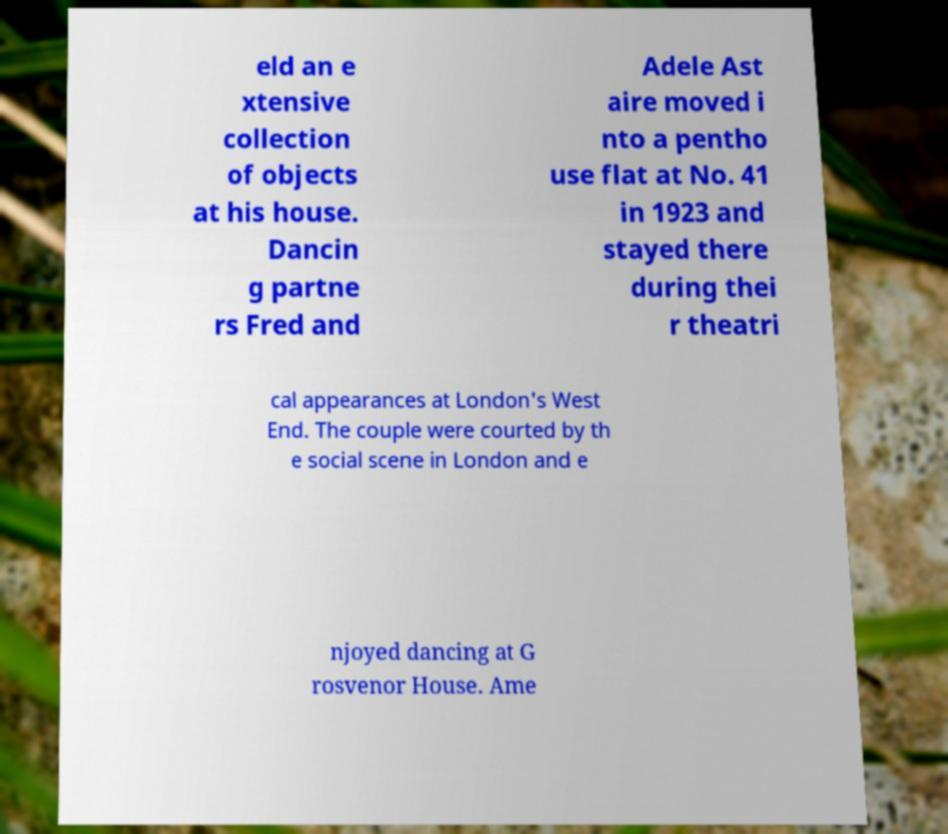Please read and relay the text visible in this image. What does it say? eld an e xtensive collection of objects at his house. Dancin g partne rs Fred and Adele Ast aire moved i nto a pentho use flat at No. 41 in 1923 and stayed there during thei r theatri cal appearances at London's West End. The couple were courted by th e social scene in London and e njoyed dancing at G rosvenor House. Ame 